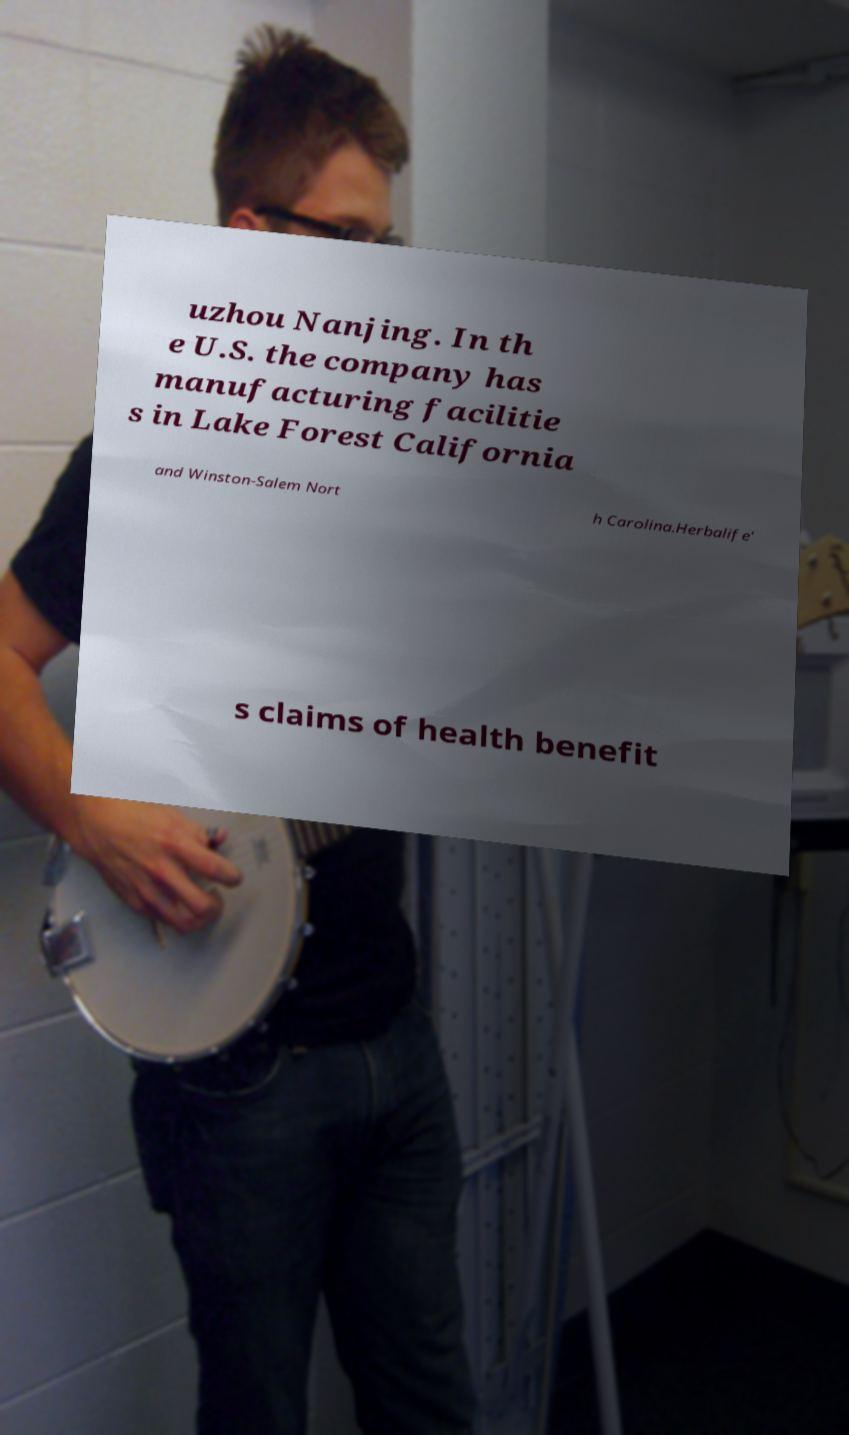Could you extract and type out the text from this image? uzhou Nanjing. In th e U.S. the company has manufacturing facilitie s in Lake Forest California and Winston-Salem Nort h Carolina.Herbalife' s claims of health benefit 